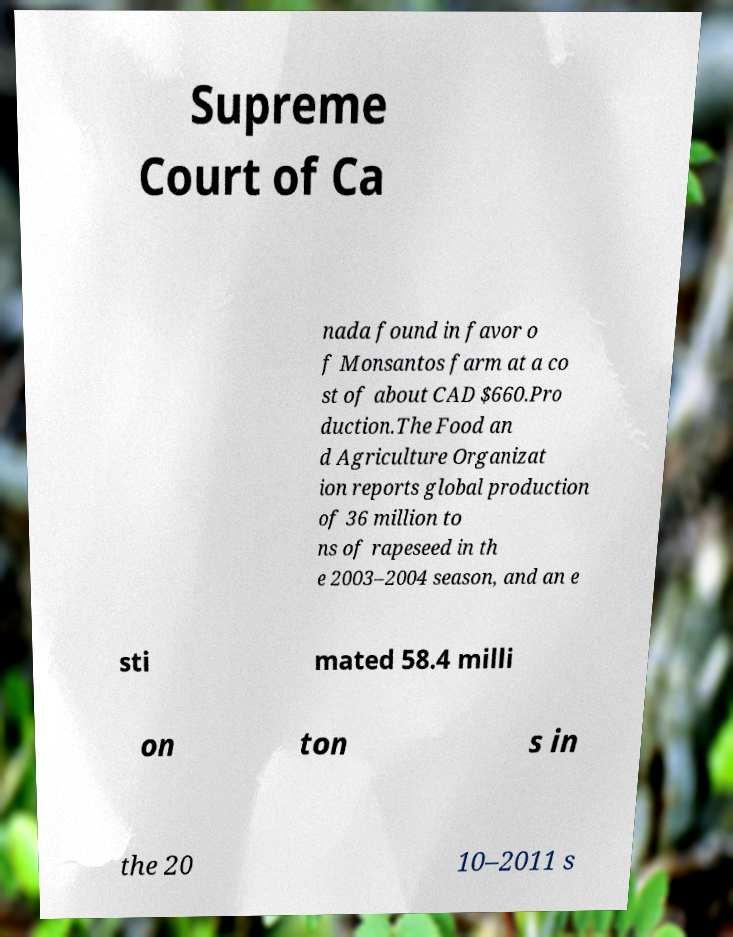Please identify and transcribe the text found in this image. Supreme Court of Ca nada found in favor o f Monsantos farm at a co st of about CAD $660.Pro duction.The Food an d Agriculture Organizat ion reports global production of 36 million to ns of rapeseed in th e 2003–2004 season, and an e sti mated 58.4 milli on ton s in the 20 10–2011 s 